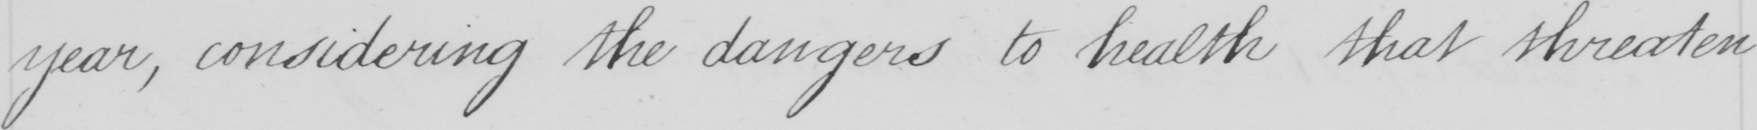Transcribe the text shown in this historical manuscript line. year , considering the dangers to health that threaten 